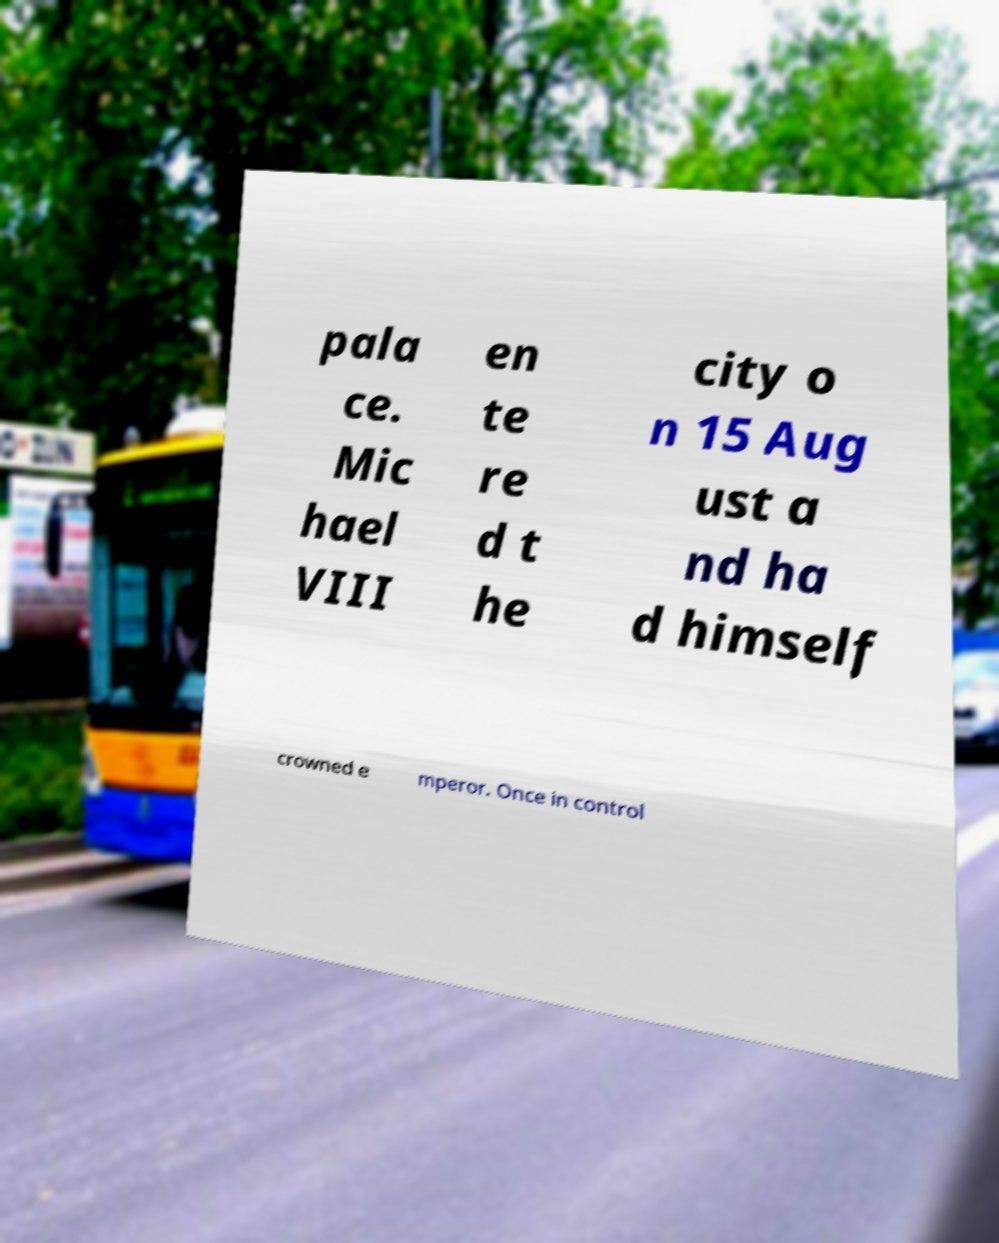For documentation purposes, I need the text within this image transcribed. Could you provide that? pala ce. Mic hael VIII en te re d t he city o n 15 Aug ust a nd ha d himself crowned e mperor. Once in control 